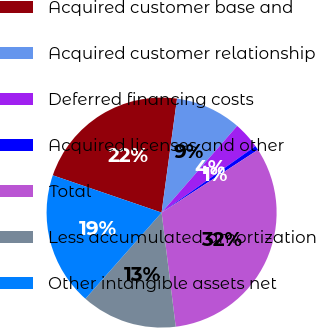Convert chart. <chart><loc_0><loc_0><loc_500><loc_500><pie_chart><fcel>Acquired customer base and<fcel>Acquired customer relationship<fcel>Deferred financing costs<fcel>Acquired licenses and other<fcel>Total<fcel>Less accumulated amortization<fcel>Other intangible assets net<nl><fcel>21.89%<fcel>9.27%<fcel>3.78%<fcel>0.62%<fcel>32.22%<fcel>13.48%<fcel>18.73%<nl></chart> 